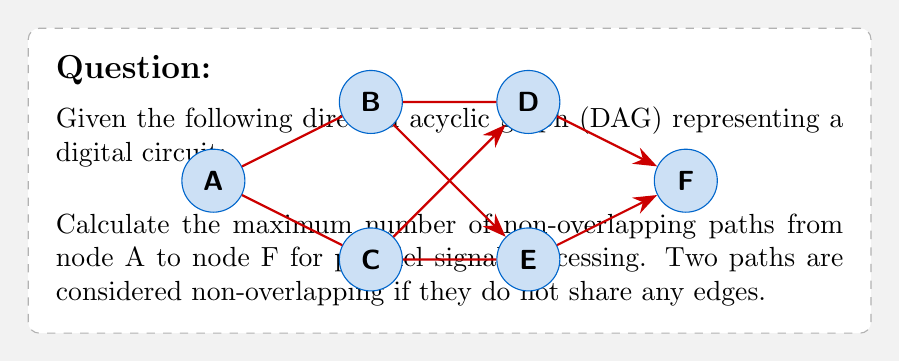Help me with this question. To solve this problem, we can use the concept of maximum flow in a graph. Here's a step-by-step approach:

1) First, we need to identify all possible paths from A to F:
   Path 1: A -> B -> D -> F
   Path 2: A -> B -> E -> F
   Path 3: A -> C -> D -> F
   Path 4: A -> C -> E -> F

2) Now, we need to find the maximum number of these paths that don't share any edges. This is equivalent to finding the maximum number of edge-disjoint paths.

3) To do this, we can use the Max-Flow Min-Cut theorem. In this case, each edge can be considered to have a capacity of 1 (as we're looking for non-overlapping paths).

4) The maximum flow from A to F will be equal to the number of edge-disjoint paths.

5) To calculate the max flow, we can use the Ford-Fulkerson algorithm:

   - First flow: A -> B -> D -> F (flow = 1)
   - Second flow: A -> C -> E -> F (flow = 2)

6) After these two flows, there are no more augmenting paths from A to F. Therefore, the maximum flow is 2.

7) This means there are at most 2 non-overlapping paths from A to F in this circuit.

These paths are:
1) A -> B -> D -> F
2) A -> C -> E -> F

These paths allow for maximum parallel signal processing in the given digital circuit.
Answer: 2 